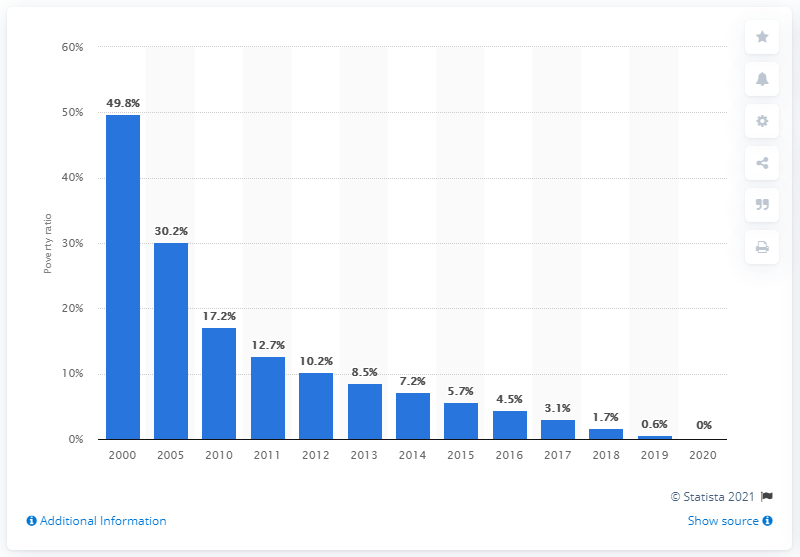Draw attention to some important aspects in this diagram. The Chinese government declared in 2020 that all residents in China had been relieved from extreme poverty. Since 2000, the share of people living in extreme poverty in rural China has been decreasing. 